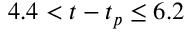Convert formula to latex. <formula><loc_0><loc_0><loc_500><loc_500>4 . 4 < t - t _ { p } \leq 6 . 2</formula> 